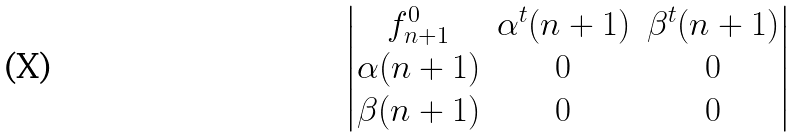Convert formula to latex. <formula><loc_0><loc_0><loc_500><loc_500>\begin{vmatrix} f _ { n + 1 } ^ { 0 } & \alpha ^ { t } ( n + 1 ) & \beta ^ { t } ( n + 1 ) \\ \alpha ( n + 1 ) & 0 & 0 \\ \beta ( n + 1 ) & 0 & 0 \\ \end{vmatrix}</formula> 